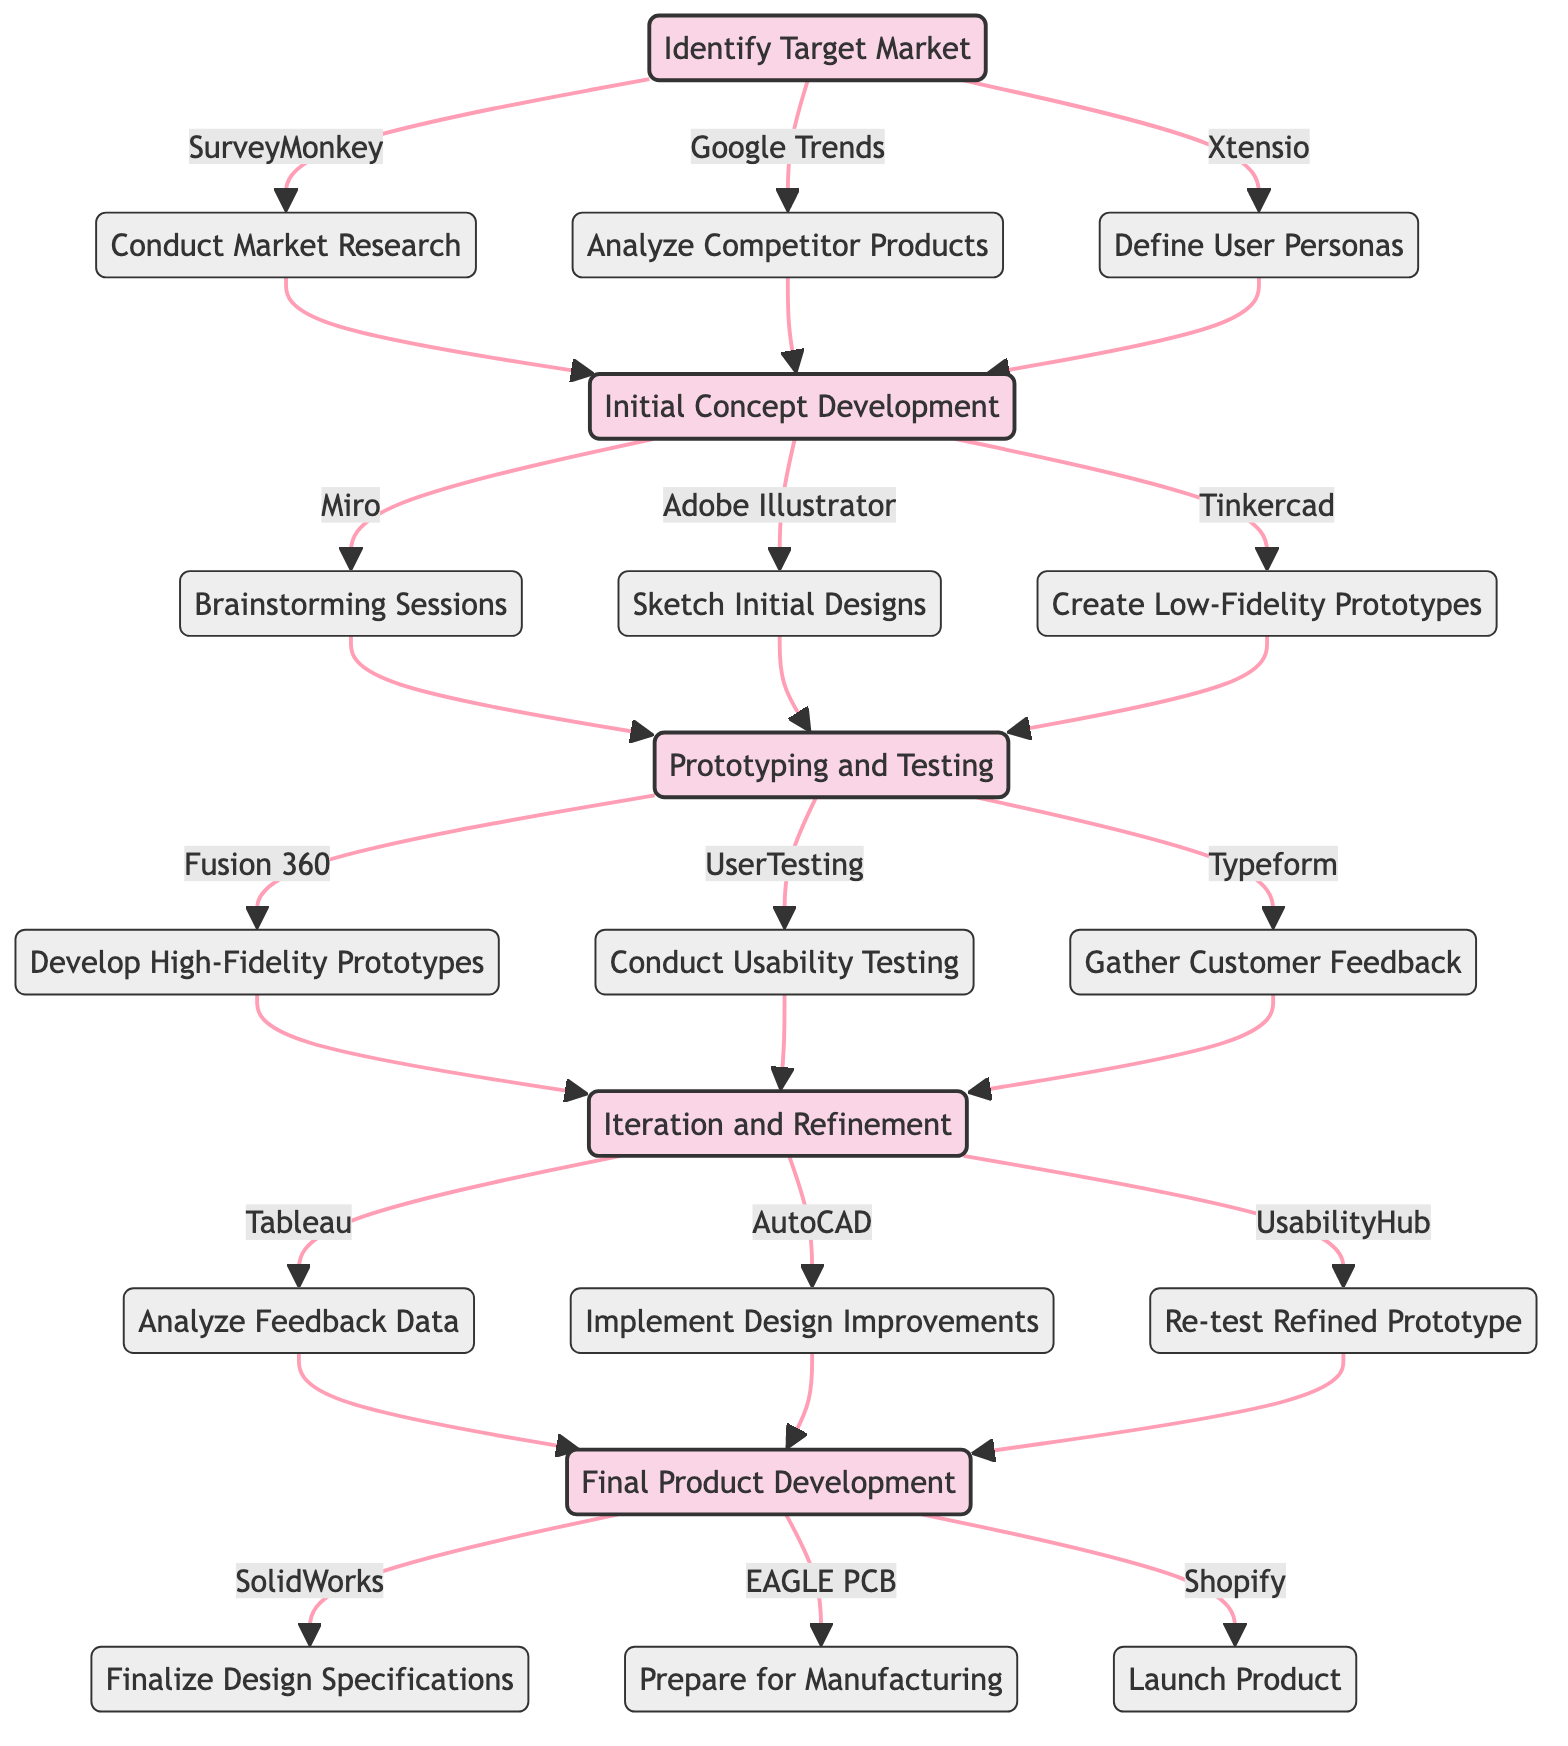What is the first phase in the clinical pathway? The first phase is labeled as "Initial Concept Development" in the diagram. This can be identified by looking for the first labeled phase after the "Start" node.
Answer: Initial Concept Development How many actions are involved in the "Prototyping and Testing" phase? In the "Prototyping and Testing" phase, there are three actions listed: "Develop High-Fidelity Prototypes," "Conduct Usability Testing," and "Gather Customer Feedback." Counting these gives a total of three actions.
Answer: 3 What tool is used for analyzing competitor products? The action associated with analyzing competitor products in the "Identify Target Market" phase lists "Google Trends" as the tool. This information can be found directly under the corresponding action in the phase.
Answer: Google Trends In which phase does gathering customer feedback occur? Gathering customer feedback is an action explicitly listed under "Phase2: Prototyping and Testing." By tracing the flow from the start, we can see this action falls within that phase.
Answer: Phase2 What follows after analyzing feedback data? The next action after "Analyze Feedback Data" is "Implement Design Improvements," as indicated by the flow direction in the diagram following the feedback analysis. This can be tracked from Phase3 to its subsequent action.
Answer: Implement Design Improvements How many total phases are present in the clinical pathway? By observing the diagram, we see five distinct phases, starting from "Start," through three phases, and concluding with "End." Therefore, the total count is five.
Answer: 5 Which tool is used for finalizing design specifications? The action that specifies finalizing design specifications mentions the use of "SolidWorks," which is directly associated with the "End" phase of the clinical pathway, as outlined in the diagram.
Answer: SolidWorks What is the last action listed in the clinical pathway? The last action in the clinical pathway is "Launch Product," which appears under the "End" phase. This can be confirmed by tracing the roadmap to the final listed items.
Answer: Launch Product What connects the "Initial Concept Development" phase to the "Prototyping and Testing" phase? The connecting actions from "Initial Concept Development" to "Prototyping and Testing" are the three actions “Brainstorming Sessions,” “Sketch Initial Designs,” and “Create Low-Fidelity Prototypes.” These actions must be completed before moving to the next phase, connection indicated by the arrows.
Answer: Brainstorming Sessions, Sketch Initial Designs, Create Low-Fidelity Prototypes 